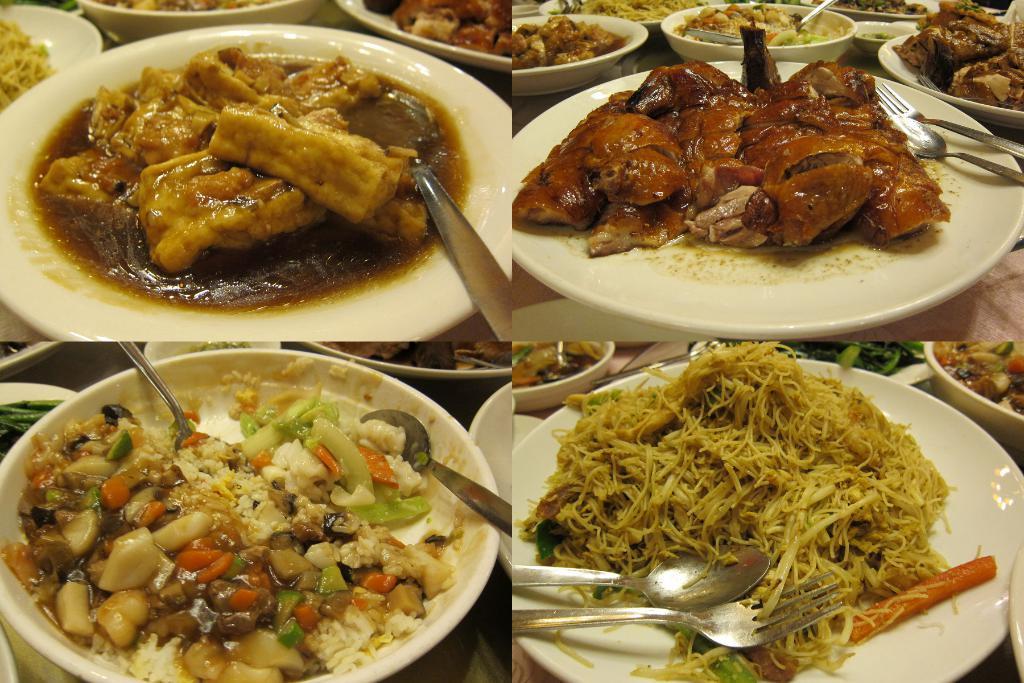In one or two sentences, can you explain what this image depicts? Here we can see collage of four pictures, in these pictures we can see plates and bowls, we can see food in these plates and bowls, we can see spoons and forks here. 